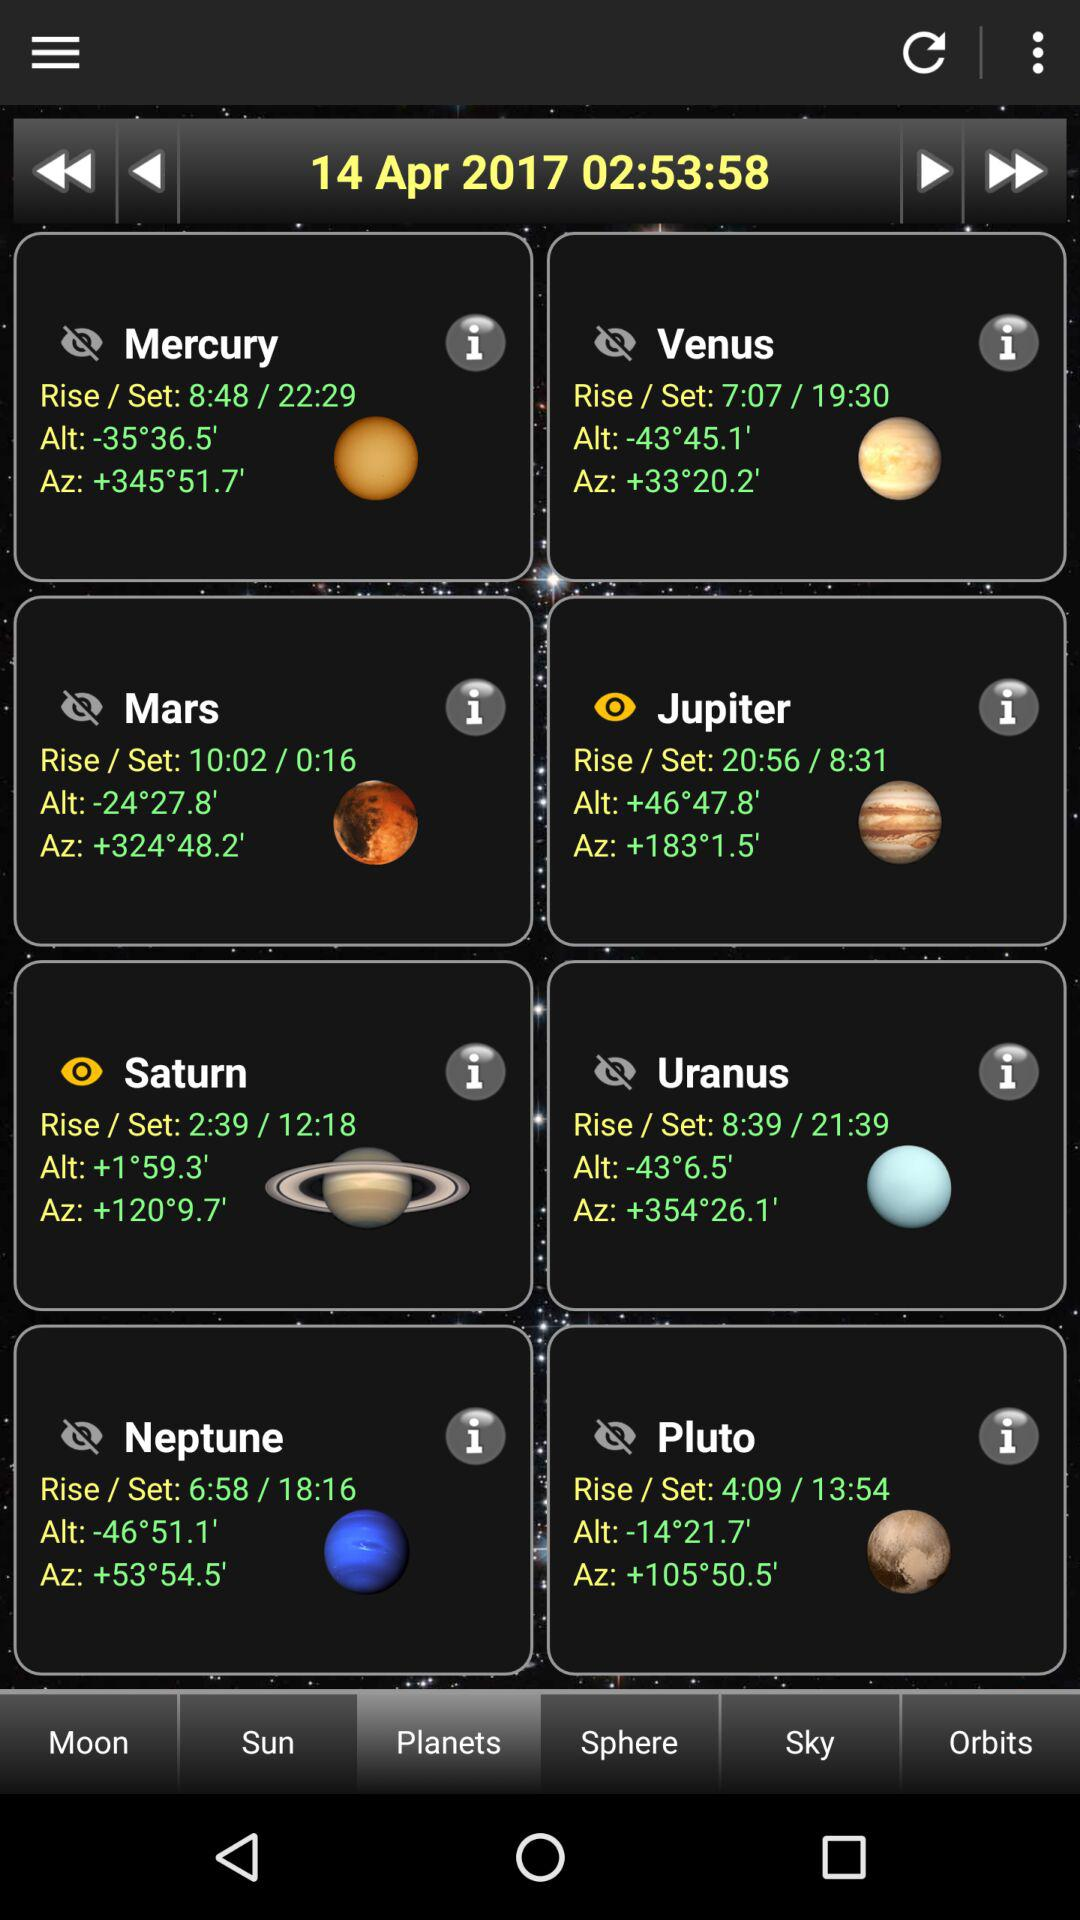What is the date and time? The date and time are April 14, 2017 and 02:53:58, respectively. 